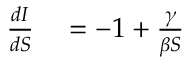<formula> <loc_0><loc_0><loc_500><loc_500>\begin{array} { r l } { { \frac { d I } { d S } } } & = - 1 + \frac { \gamma } { \beta S } } \end{array}</formula> 